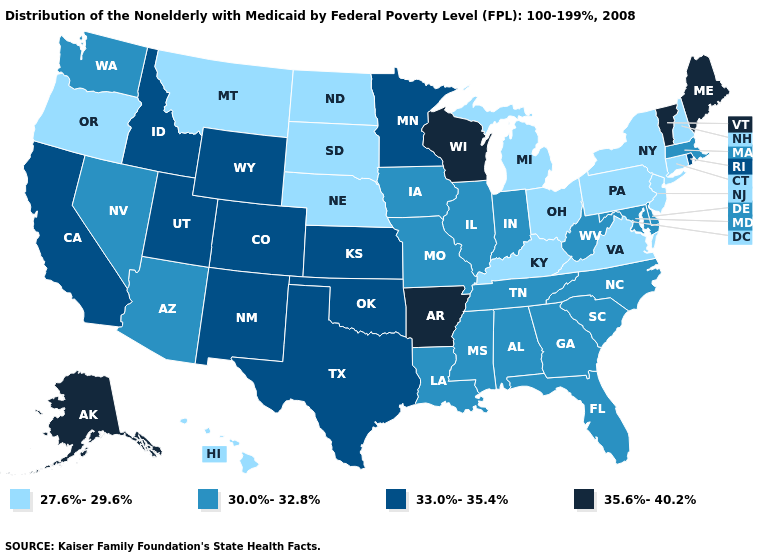Name the states that have a value in the range 35.6%-40.2%?
Give a very brief answer. Alaska, Arkansas, Maine, Vermont, Wisconsin. Name the states that have a value in the range 33.0%-35.4%?
Give a very brief answer. California, Colorado, Idaho, Kansas, Minnesota, New Mexico, Oklahoma, Rhode Island, Texas, Utah, Wyoming. Does Rhode Island have the same value as Louisiana?
Write a very short answer. No. What is the value of Iowa?
Concise answer only. 30.0%-32.8%. Name the states that have a value in the range 35.6%-40.2%?
Keep it brief. Alaska, Arkansas, Maine, Vermont, Wisconsin. What is the value of Nevada?
Quick response, please. 30.0%-32.8%. What is the value of Wyoming?
Be succinct. 33.0%-35.4%. What is the value of Arizona?
Answer briefly. 30.0%-32.8%. Among the states that border New Hampshire , does Massachusetts have the highest value?
Give a very brief answer. No. Does Maine have the same value as Arkansas?
Keep it brief. Yes. What is the value of New Hampshire?
Keep it brief. 27.6%-29.6%. What is the lowest value in states that border New Hampshire?
Concise answer only. 30.0%-32.8%. Does Arizona have the lowest value in the USA?
Concise answer only. No. What is the highest value in the USA?
Concise answer only. 35.6%-40.2%. Which states have the lowest value in the USA?
Short answer required. Connecticut, Hawaii, Kentucky, Michigan, Montana, Nebraska, New Hampshire, New Jersey, New York, North Dakota, Ohio, Oregon, Pennsylvania, South Dakota, Virginia. 